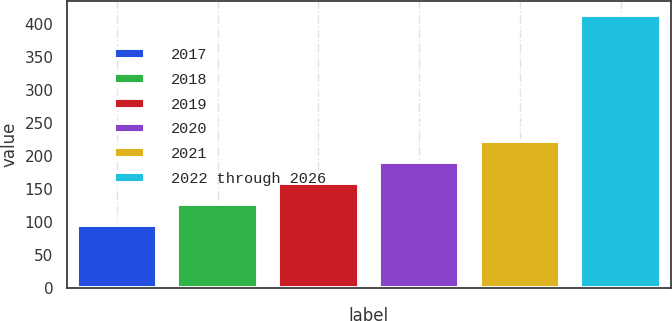<chart> <loc_0><loc_0><loc_500><loc_500><bar_chart><fcel>2017<fcel>2018<fcel>2019<fcel>2020<fcel>2021<fcel>2022 through 2026<nl><fcel>95<fcel>127<fcel>159<fcel>191<fcel>223<fcel>415<nl></chart> 